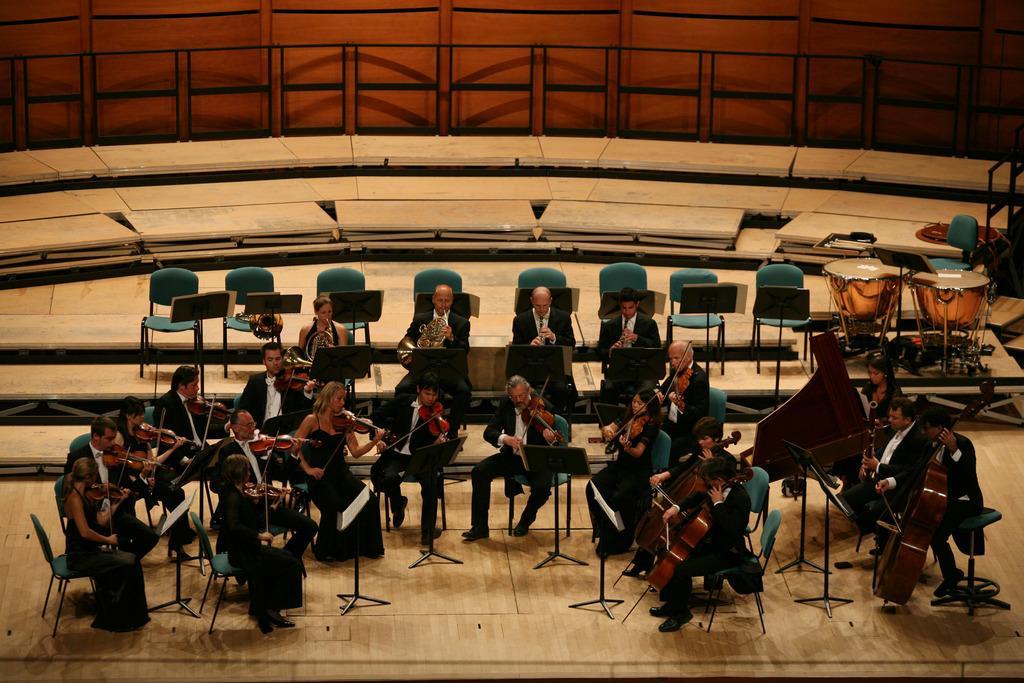Describe this image in one or two sentences. In this image I can see number of people are sitting on chairs and holding musical instruments. I can also see stands and few more chairs in the background. Here I can see two drums. 